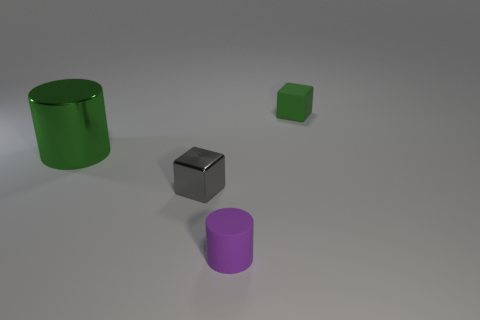Add 1 big yellow blocks. How many objects exist? 5 Subtract all big shiny things. Subtract all tiny matte cylinders. How many objects are left? 2 Add 4 tiny green cubes. How many tiny green cubes are left? 5 Add 4 tiny green rubber objects. How many tiny green rubber objects exist? 5 Subtract 1 green cylinders. How many objects are left? 3 